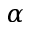Convert formula to latex. <formula><loc_0><loc_0><loc_500><loc_500>\alpha</formula> 